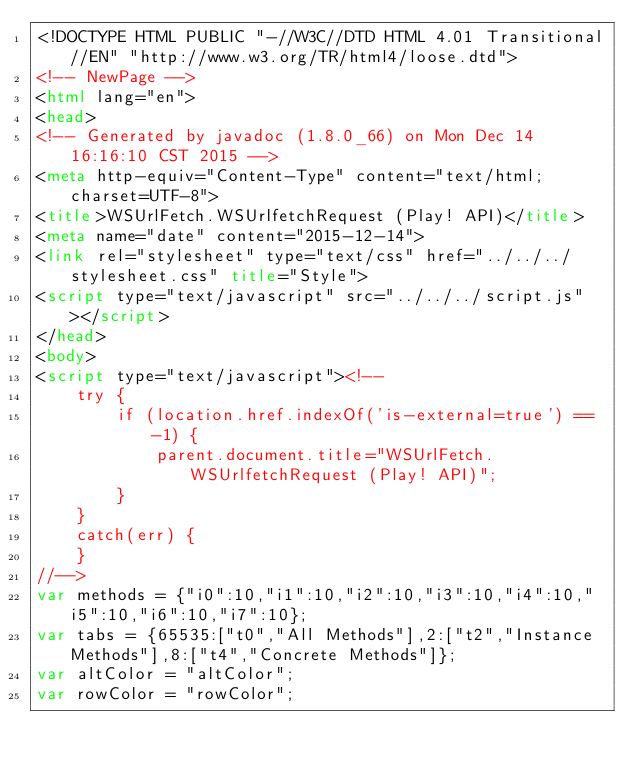<code> <loc_0><loc_0><loc_500><loc_500><_HTML_><!DOCTYPE HTML PUBLIC "-//W3C//DTD HTML 4.01 Transitional//EN" "http://www.w3.org/TR/html4/loose.dtd">
<!-- NewPage -->
<html lang="en">
<head>
<!-- Generated by javadoc (1.8.0_66) on Mon Dec 14 16:16:10 CST 2015 -->
<meta http-equiv="Content-Type" content="text/html; charset=UTF-8">
<title>WSUrlFetch.WSUrlfetchRequest (Play! API)</title>
<meta name="date" content="2015-12-14">
<link rel="stylesheet" type="text/css" href="../../../stylesheet.css" title="Style">
<script type="text/javascript" src="../../../script.js"></script>
</head>
<body>
<script type="text/javascript"><!--
    try {
        if (location.href.indexOf('is-external=true') == -1) {
            parent.document.title="WSUrlFetch.WSUrlfetchRequest (Play! API)";
        }
    }
    catch(err) {
    }
//-->
var methods = {"i0":10,"i1":10,"i2":10,"i3":10,"i4":10,"i5":10,"i6":10,"i7":10};
var tabs = {65535:["t0","All Methods"],2:["t2","Instance Methods"],8:["t4","Concrete Methods"]};
var altColor = "altColor";
var rowColor = "rowColor";</code> 